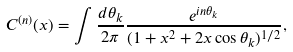<formula> <loc_0><loc_0><loc_500><loc_500>C ^ { ( n ) } ( x ) = \int \frac { d \theta _ { k } } { 2 \pi } \frac { e ^ { i n \theta _ { k } } } { ( 1 + x ^ { 2 } + 2 x \cos \theta _ { k } ) ^ { 1 / 2 } } ,</formula> 